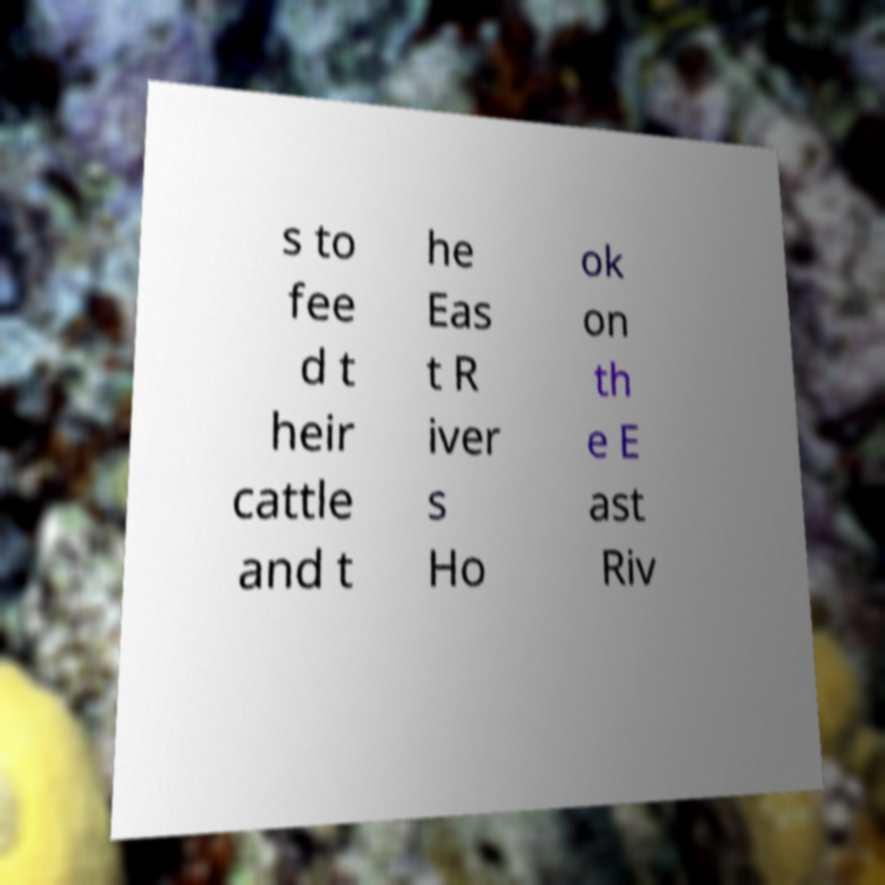Please identify and transcribe the text found in this image. s to fee d t heir cattle and t he Eas t R iver s Ho ok on th e E ast Riv 